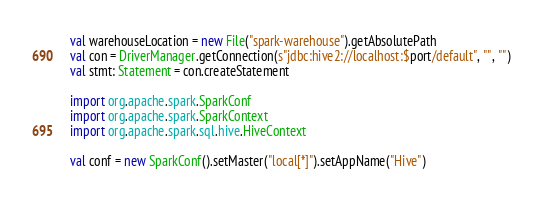<code> <loc_0><loc_0><loc_500><loc_500><_Scala_>
  val warehouseLocation = new File("spark-warehouse").getAbsolutePath
  val con = DriverManager.getConnection(s"jdbc:hive2://localhost:$port/default", "", "")
  val stmt: Statement = con.createStatement

  import org.apache.spark.SparkConf
  import org.apache.spark.SparkContext
  import org.apache.spark.sql.hive.HiveContext

  val conf = new SparkConf().setMaster("local[*]").setAppName("Hive")</code> 